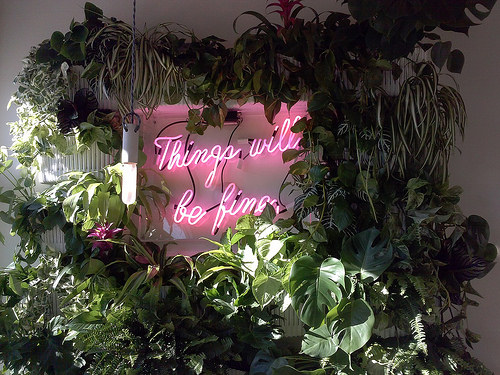<image>
Is the sign above the bush? Yes. The sign is positioned above the bush in the vertical space, higher up in the scene. 